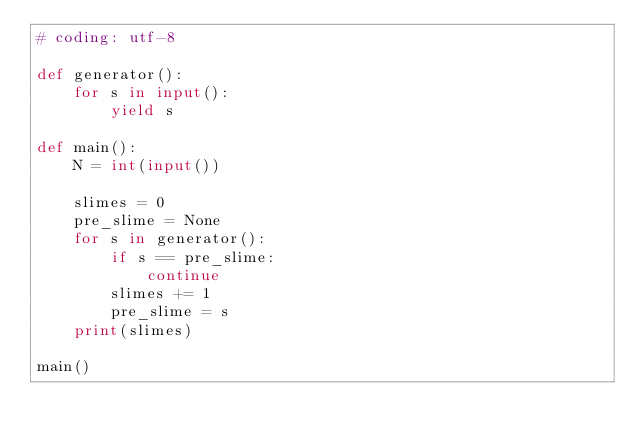<code> <loc_0><loc_0><loc_500><loc_500><_Python_># coding: utf-8

def generator():
    for s in input():
        yield s

def main():
    N = int(input())

    slimes = 0
    pre_slime = None
    for s in generator():
        if s == pre_slime:
            continue
        slimes += 1
        pre_slime = s
    print(slimes) 

main()</code> 